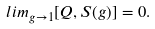<formula> <loc_0><loc_0><loc_500><loc_500>l i m _ { g \to 1 } [ Q , S ( g ) ] = 0 .</formula> 